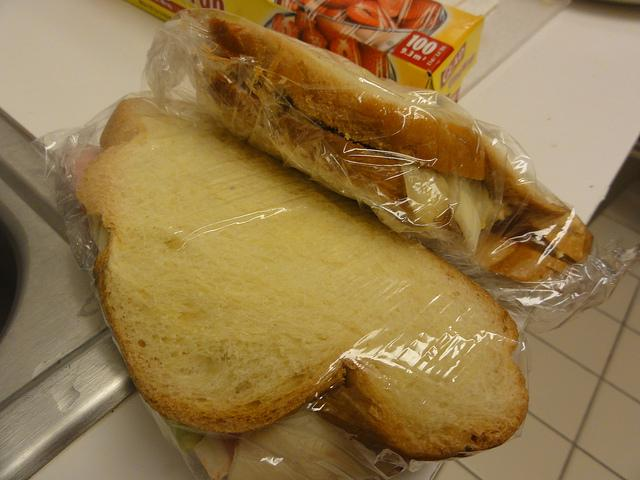What has made the sandwiches to look shiny? Please explain your reasoning. saran wrap. It's the plastic used to preserve the food. 